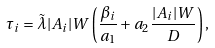Convert formula to latex. <formula><loc_0><loc_0><loc_500><loc_500>\tau _ { i } = \tilde { \lambda } | A _ { i } | W \left ( \frac { \beta _ { i } } { a _ { 1 } } + a _ { 2 } \frac { | A _ { i } | W } { D } \right ) ,</formula> 